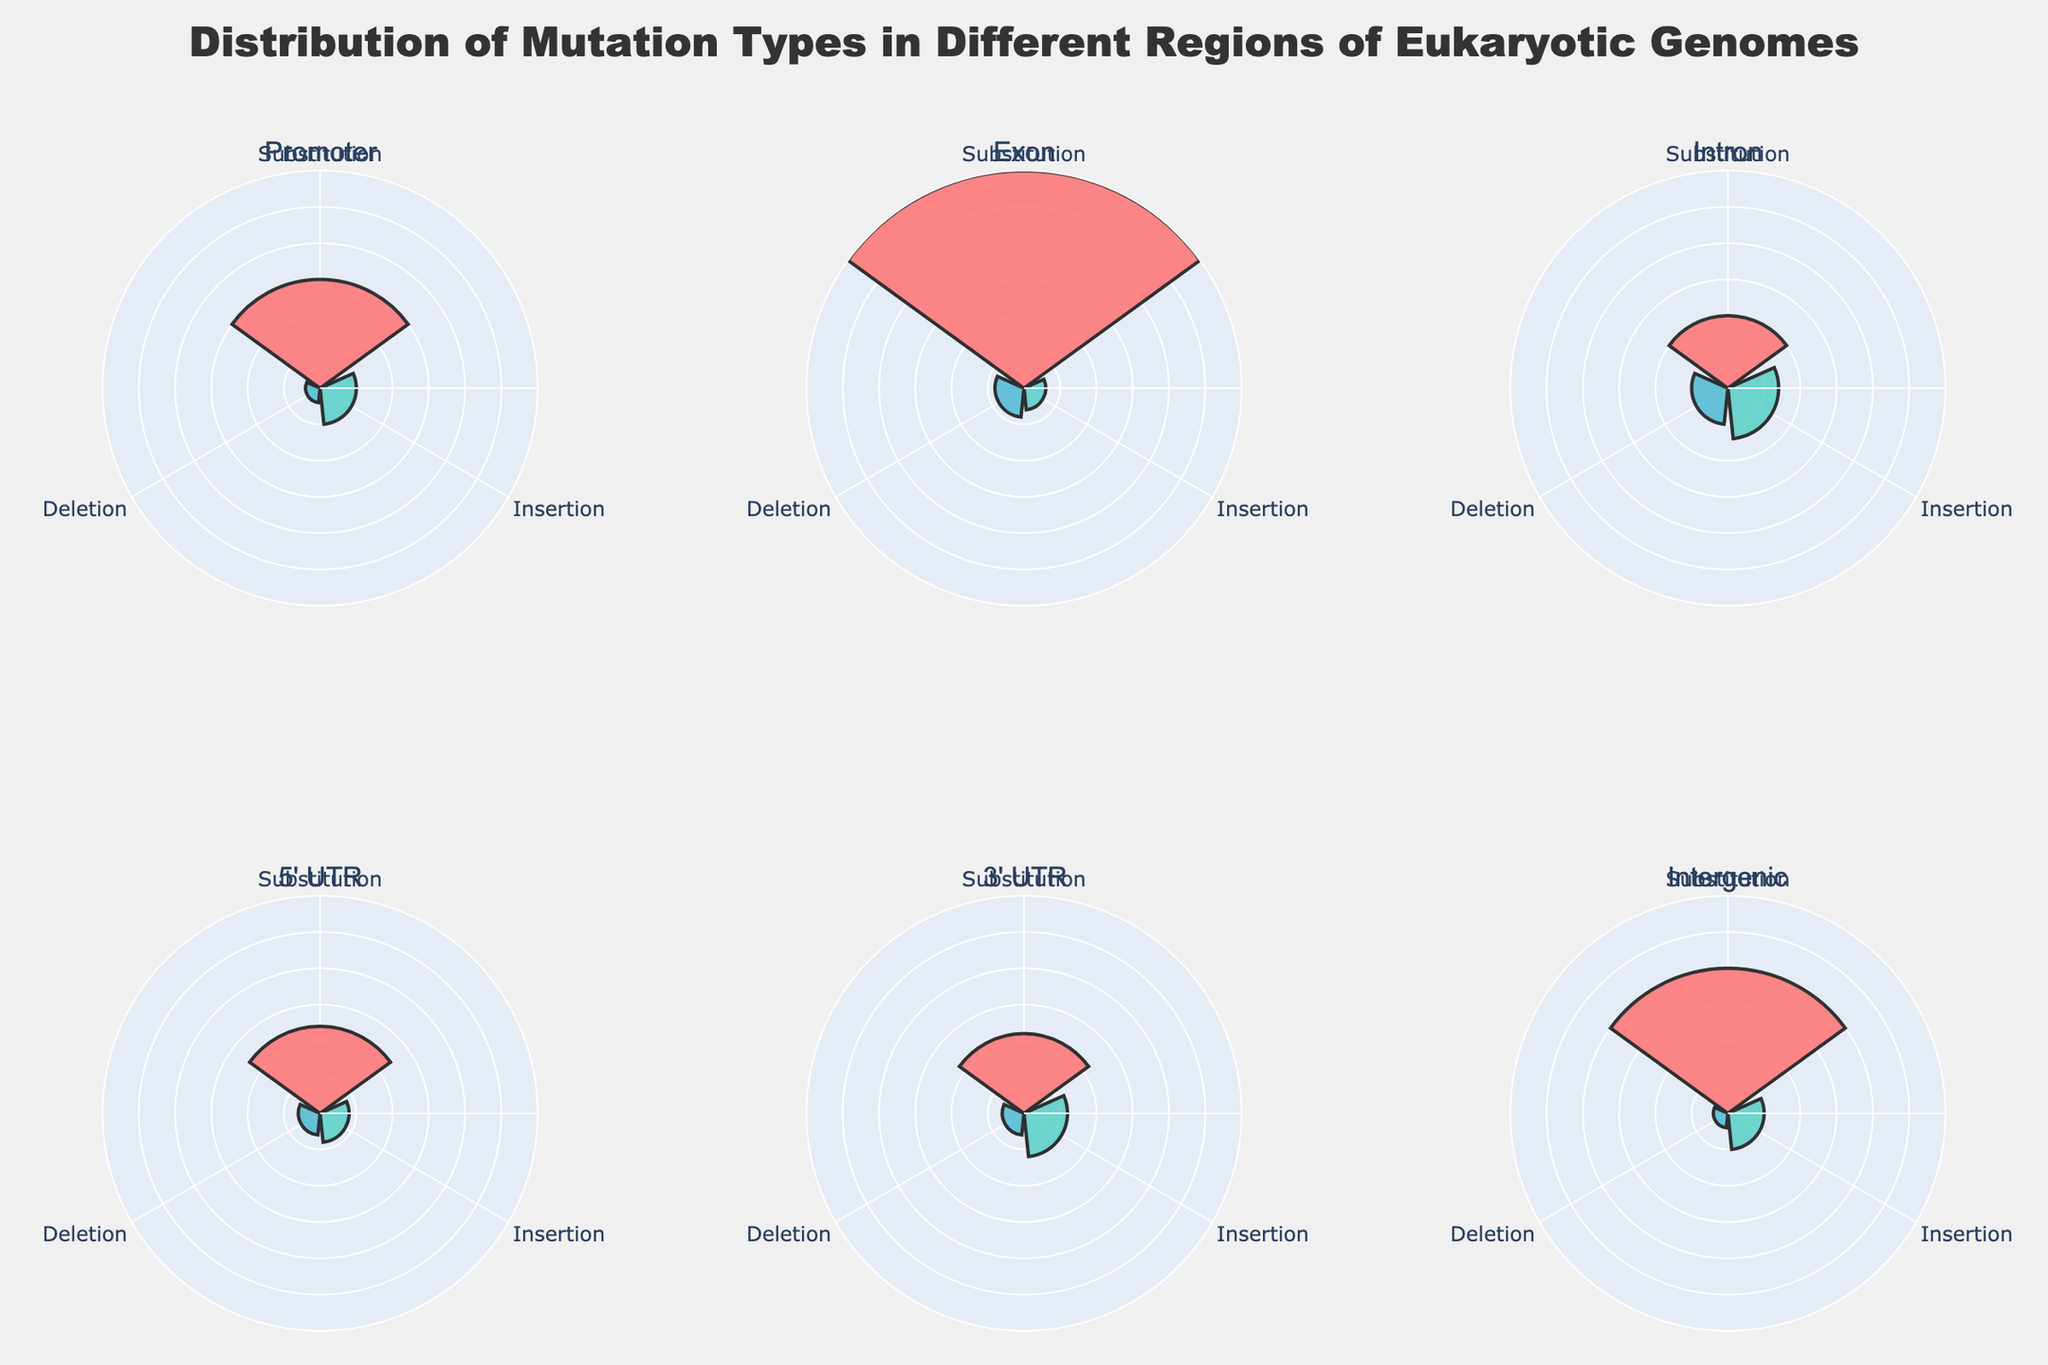What is the title of the figure? The title of the figure is displayed at the top and reads "Distribution of Mutation Types in Different Regions of Eukaryotic Genomes".
Answer: Distribution of Mutation Types in Different Regions of Eukaryotic Genomes Which region has the highest proportion of deletions? By looking at the radial extent of the 'Deletion' section in each subplot, the exon region has the highest radial length for deletions.
Answer: Exon Compare the proportions of substitutions in the 5' UTR region and promoter region. Which is higher? By comparing the lengths of the 'Substitution' section in the rose chart subplots for both regions, the promoter region has a higher proportion of substitutions than the 5' UTR region.
Answer: Promoter What is the sum of the proportions of insertions and deletions in the intron region? The proportion of insertions in the intron region is 0.07, and the proportion of deletions is 0.05. Summing them up gives 0.07 + 0.05 = 0.12.
Answer: 0.12 Which mutation type has the lowest proportion in the intergenic region? By examining the radial extents in the intergenic subplot, the 'Deletion' section has the shortest length, indicating it has the lowest proportion.
Answer: Deletion How does the total proportion of mutations in the exon region compare to the total proportion in the 5' UTR region? The total proportion of mutations in the exon region is 0.37, and the total proportion in the 5' UTR region is 0.19. Comparing these, the exon region has a higher total proportion of mutations.
Answer: Exon What is the proportion of insertions in the 3' UTR region? By looking at the radial extent of the 'Insertion' section in the 3' UTR subplot, the proportion of insertions is 0.06.
Answer: 0.06 Calculate the difference in proportions of substitutions between the promoter and intron regions. The proportion of substitutions in the promoter region is 0.15, and in the intron region is 0.10. The difference is 0.15 - 0.10 = 0.05.
Answer: 0.05 Which mutation type has the highest proportion across all regions? By looking at each of the plots, the substitution type appears to have the longest radial lengths in most of the regions, implying it has the highest proportion across all regions.
Answer: Substitution 